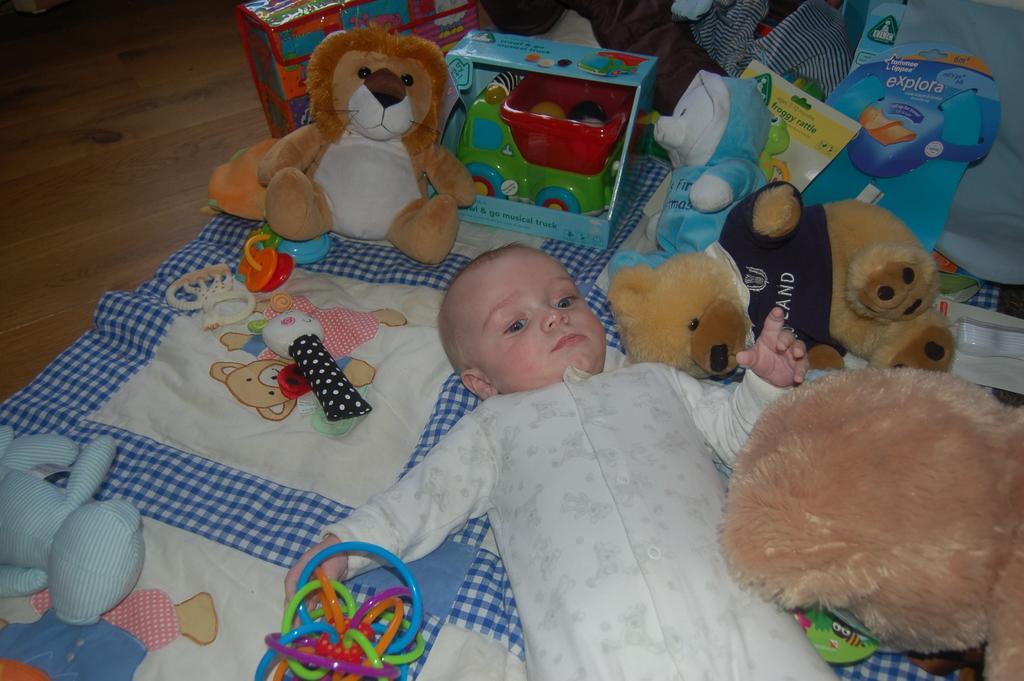Please provide a concise description of this image. In this image we can see a kid lying on the bed, there are some teddy bears, toys and some other objects. 